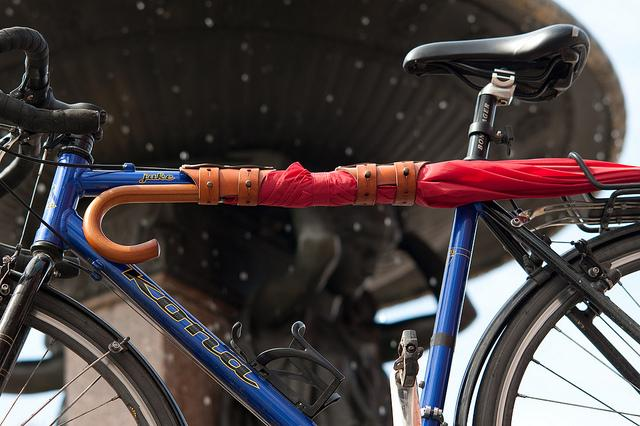What color is the umbrella strapped onto the bicycle frame's center bar? Please explain your reasoning. red. The umbrella is not the same color as the blue bicycle frame. the umbrella is not green or yellow. 